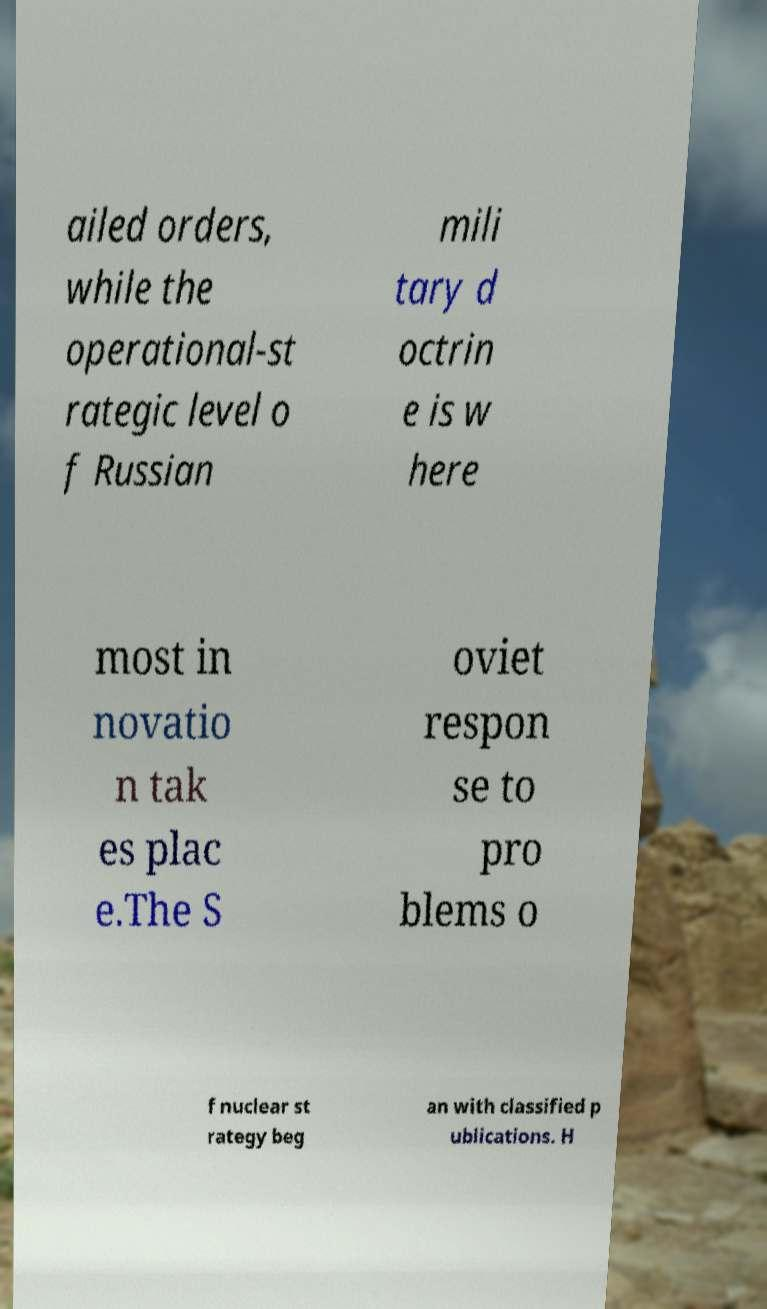Can you accurately transcribe the text from the provided image for me? ailed orders, while the operational-st rategic level o f Russian mili tary d octrin e is w here most in novatio n tak es plac e.The S oviet respon se to pro blems o f nuclear st rategy beg an with classified p ublications. H 